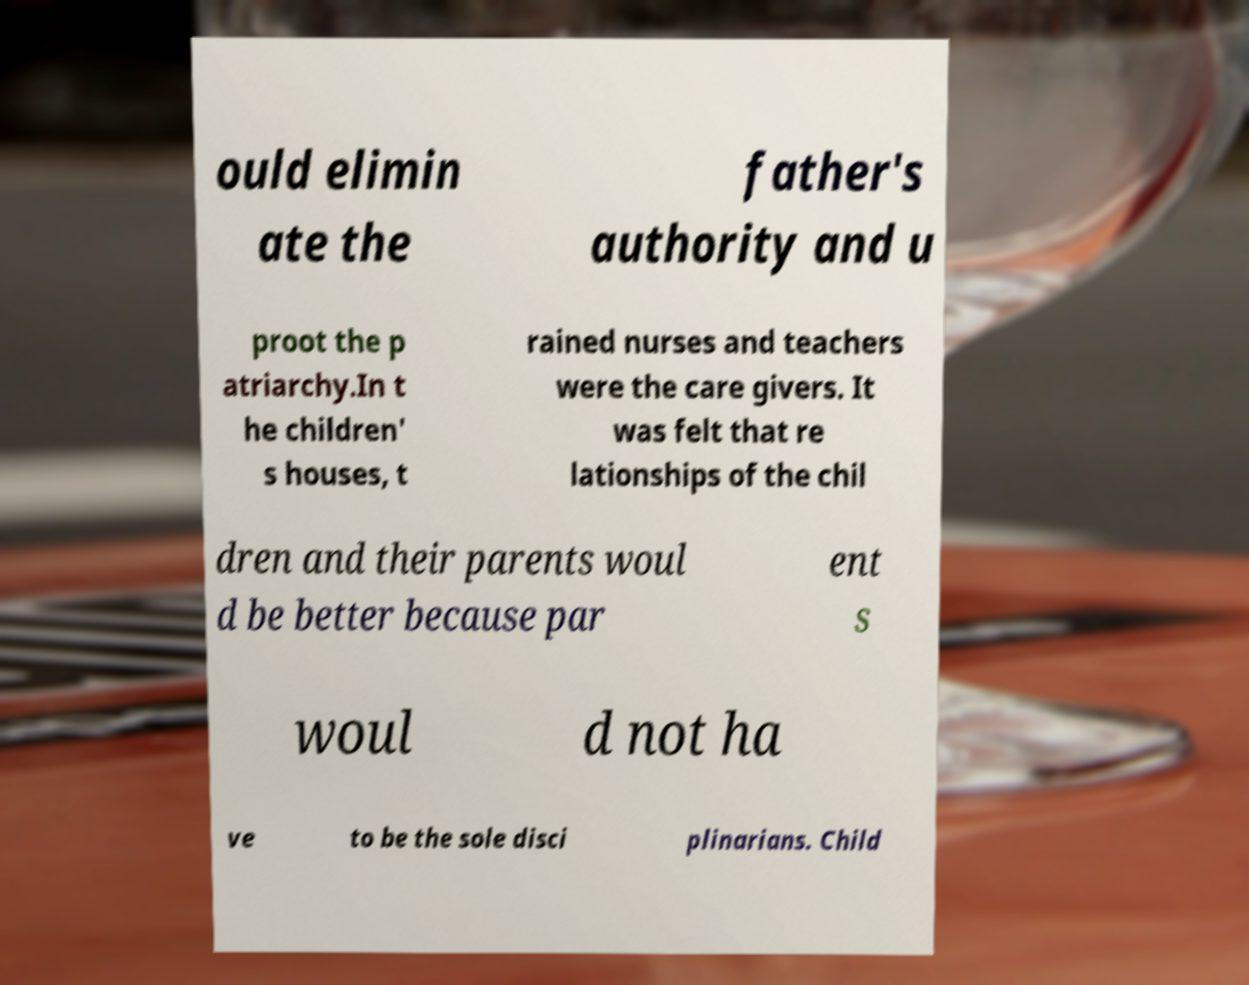There's text embedded in this image that I need extracted. Can you transcribe it verbatim? ould elimin ate the father's authority and u proot the p atriarchy.In t he children' s houses, t rained nurses and teachers were the care givers. It was felt that re lationships of the chil dren and their parents woul d be better because par ent s woul d not ha ve to be the sole disci plinarians. Child 